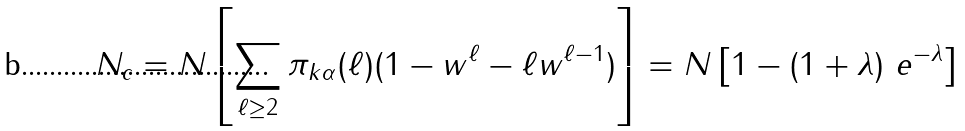Convert formula to latex. <formula><loc_0><loc_0><loc_500><loc_500>N _ { c } = N \left [ \sum _ { \ell \geq 2 } \pi _ { k \alpha } ( \ell ) ( 1 - w ^ { \ell } - \ell w ^ { \ell - 1 } ) \right ] = N \left [ 1 - ( 1 + \lambda ) \ e ^ { - \lambda } \right ]</formula> 